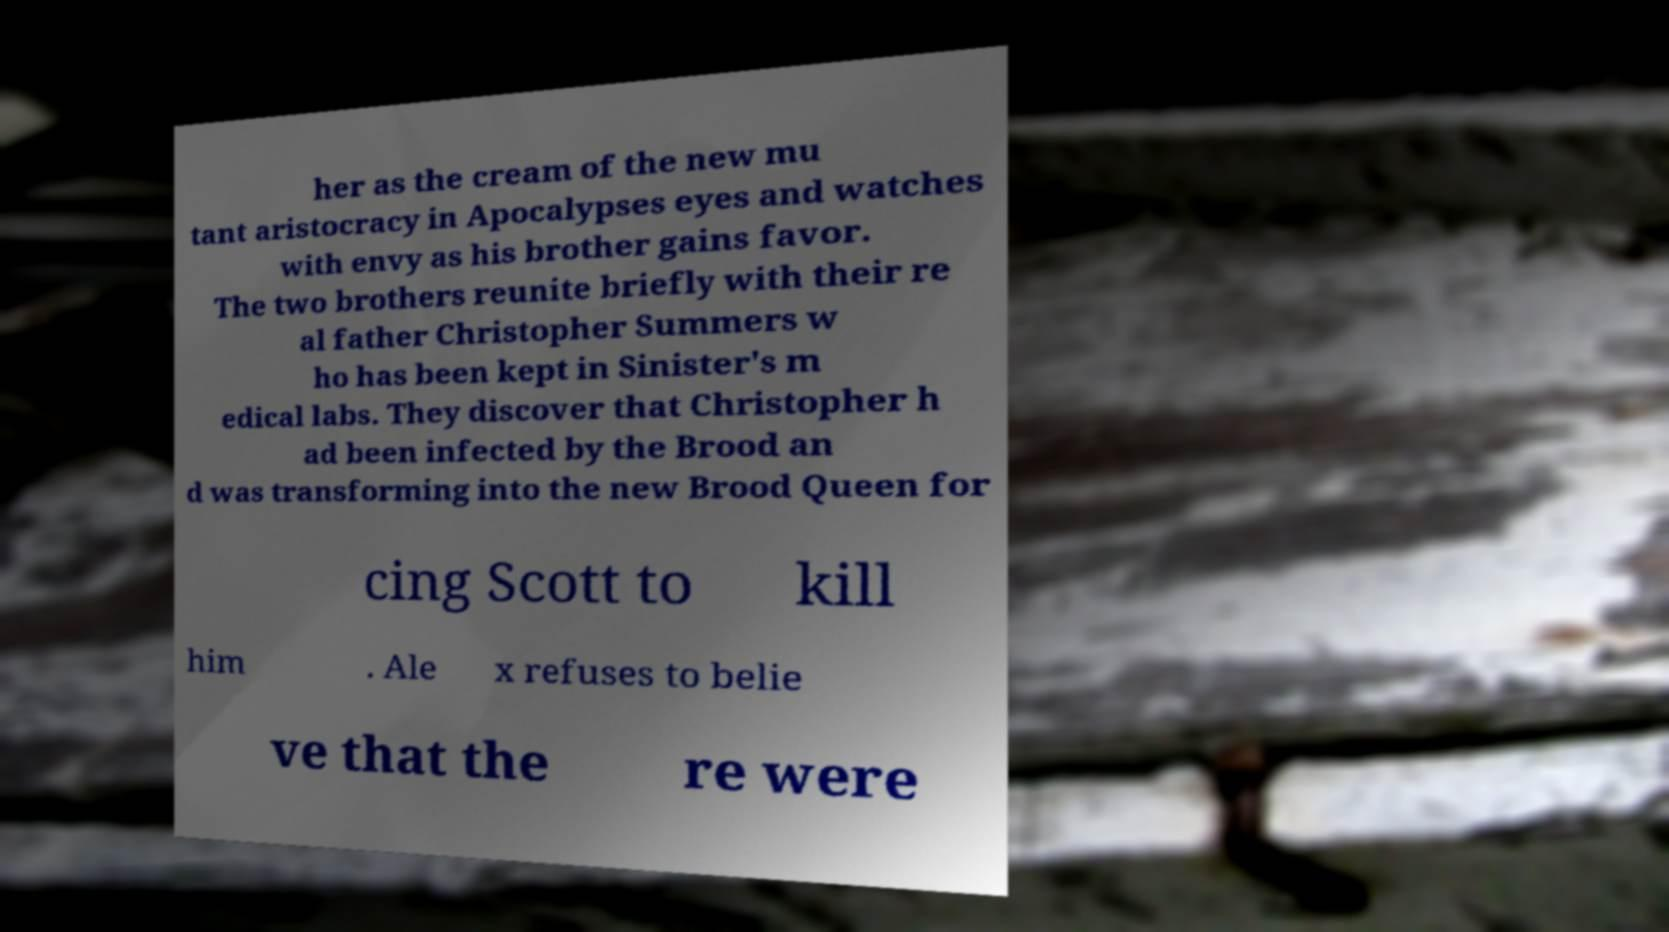Please read and relay the text visible in this image. What does it say? her as the cream of the new mu tant aristocracy in Apocalypses eyes and watches with envy as his brother gains favor. The two brothers reunite briefly with their re al father Christopher Summers w ho has been kept in Sinister's m edical labs. They discover that Christopher h ad been infected by the Brood an d was transforming into the new Brood Queen for cing Scott to kill him . Ale x refuses to belie ve that the re were 